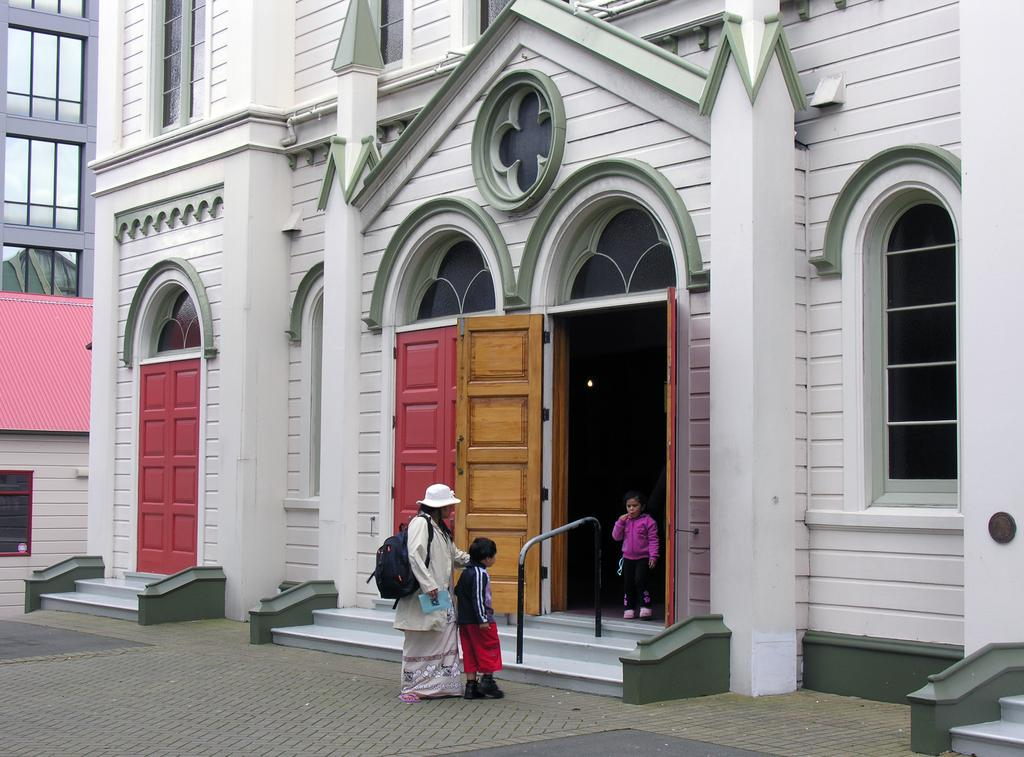What type of structures are visible in the image? There are buildings in the image. What features can be seen on the buildings? There are doors and windows visible on the buildings. Are there any individuals present in the image? Yes, there are people in the image. What object can be seen in the image that is not related to the buildings or people? There is a rod in the image. What type of vegetable is being used as a writing tool in the image? There is no vegetable being used as a writing tool in the image. Can you identify the type of engine used in the buildings in the image? There is no information about engines in the image; it only shows buildings, doors, windows, and people. 